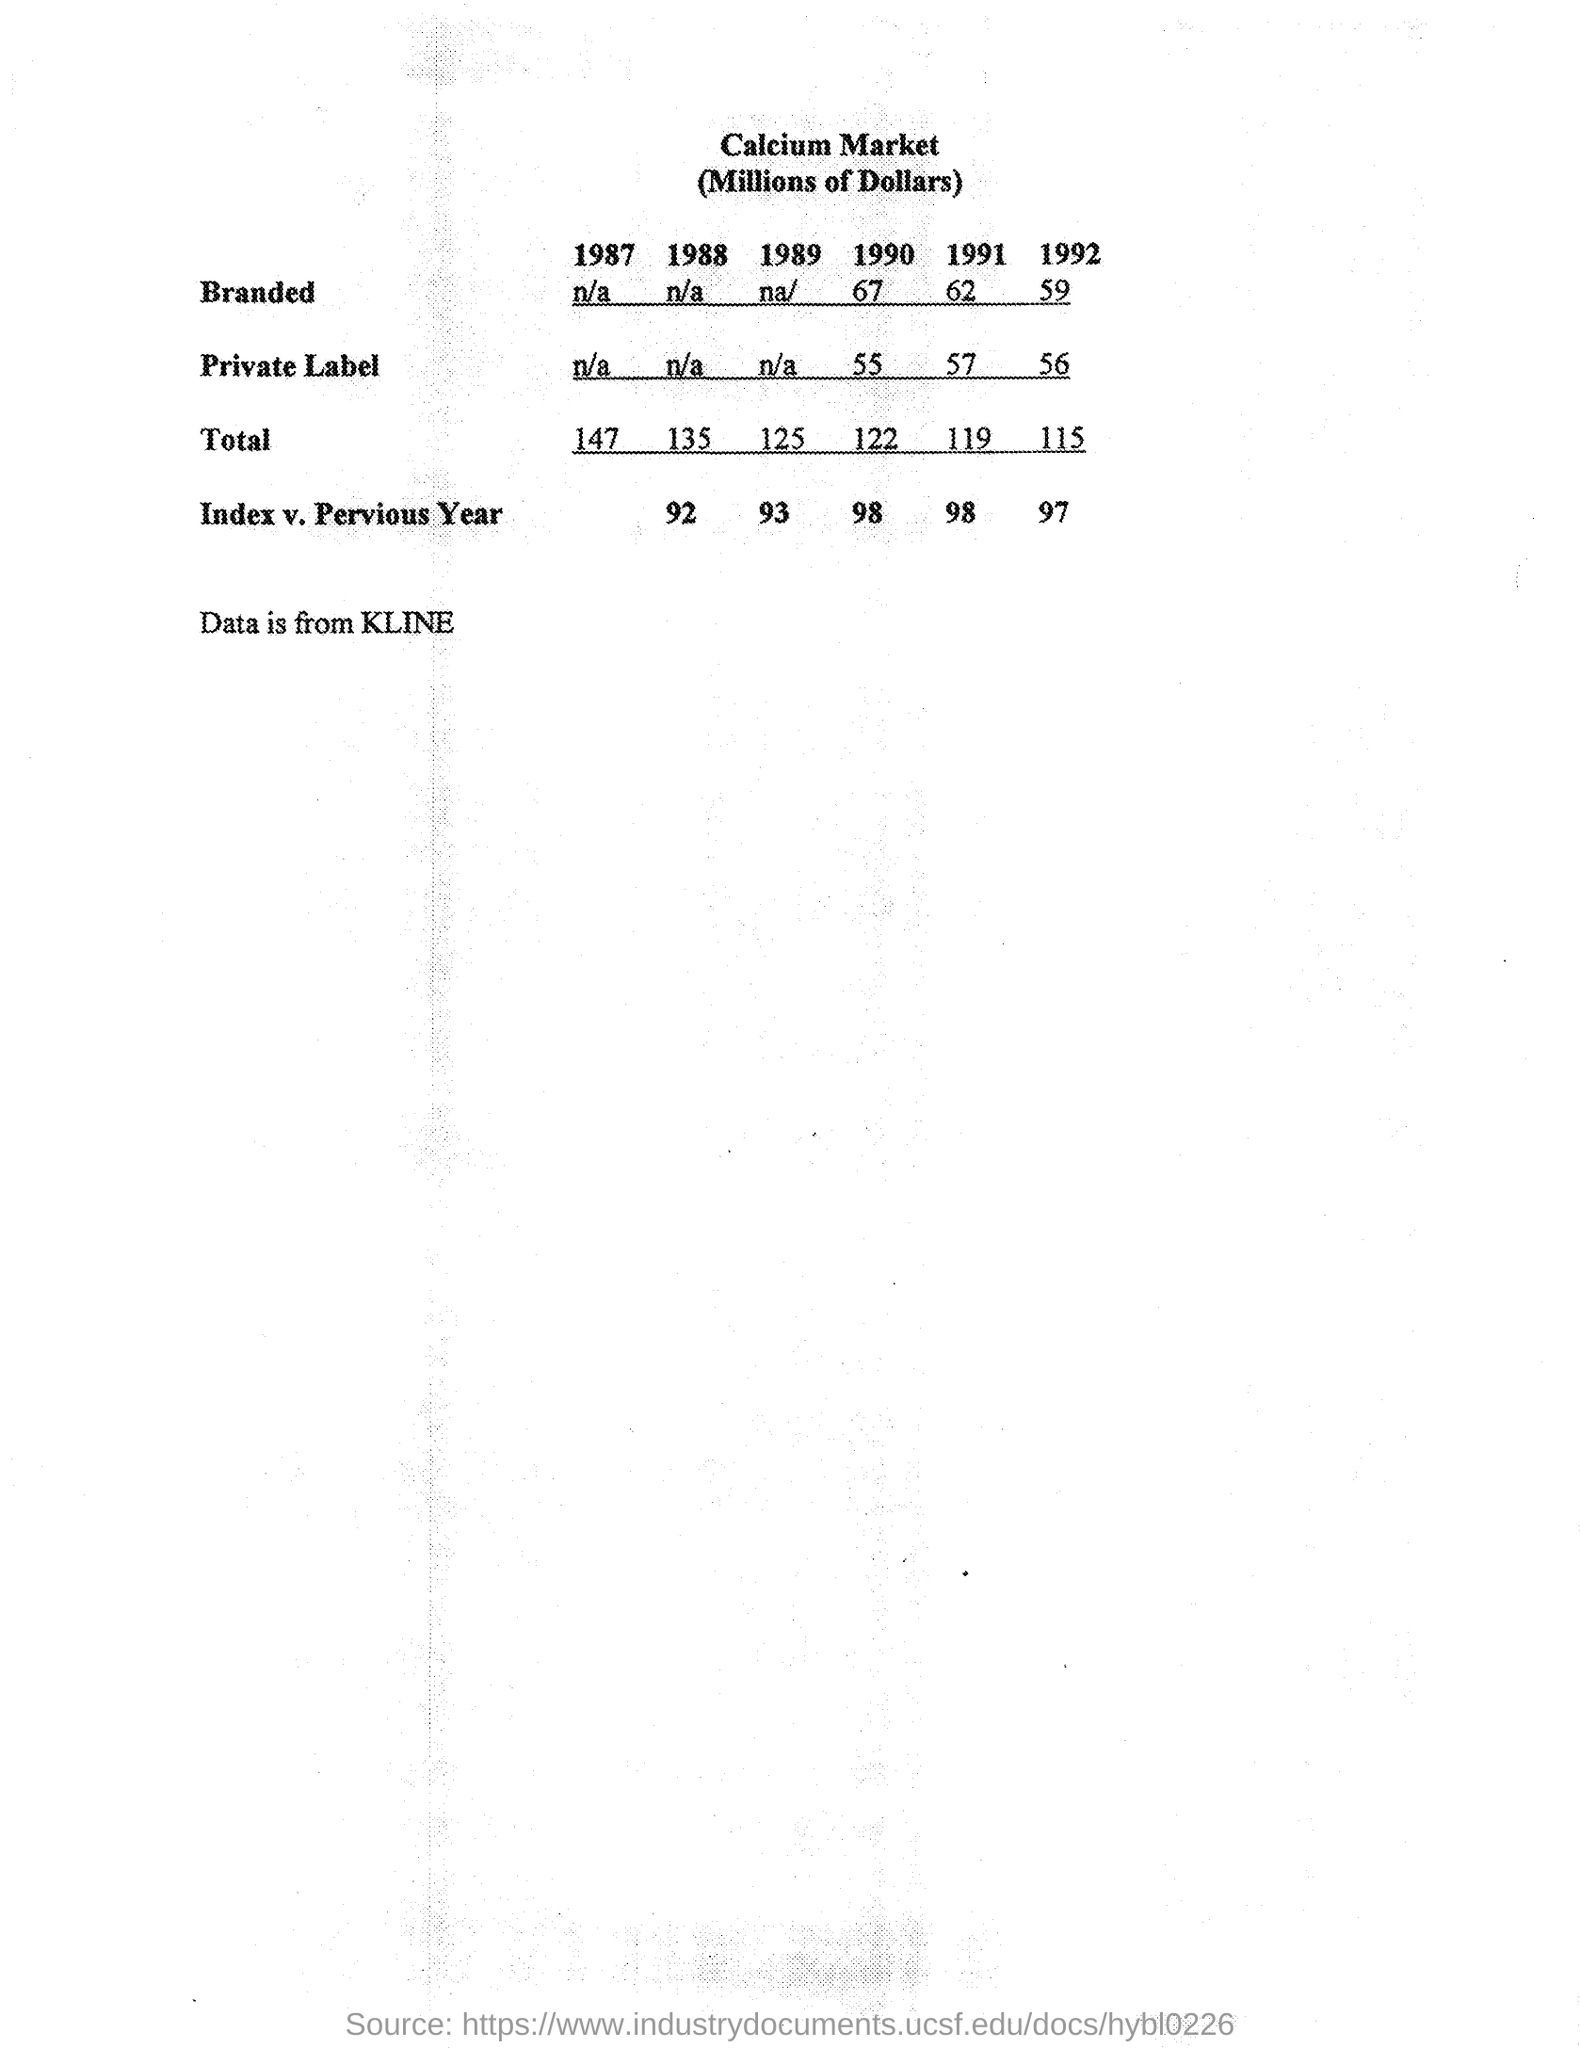Identify some key points in this picture. According to data from 1988, the total calcium market reached 135 million dollars. The Index from the previous year for the year 1989 was 93. The index from the previous year for the year 1990 was 98. The data is collected from KLINE. The total market for calcium in 1989 was valued at approximately 125 million dollars. 